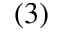<formula> <loc_0><loc_0><loc_500><loc_500>( 3 )</formula> 